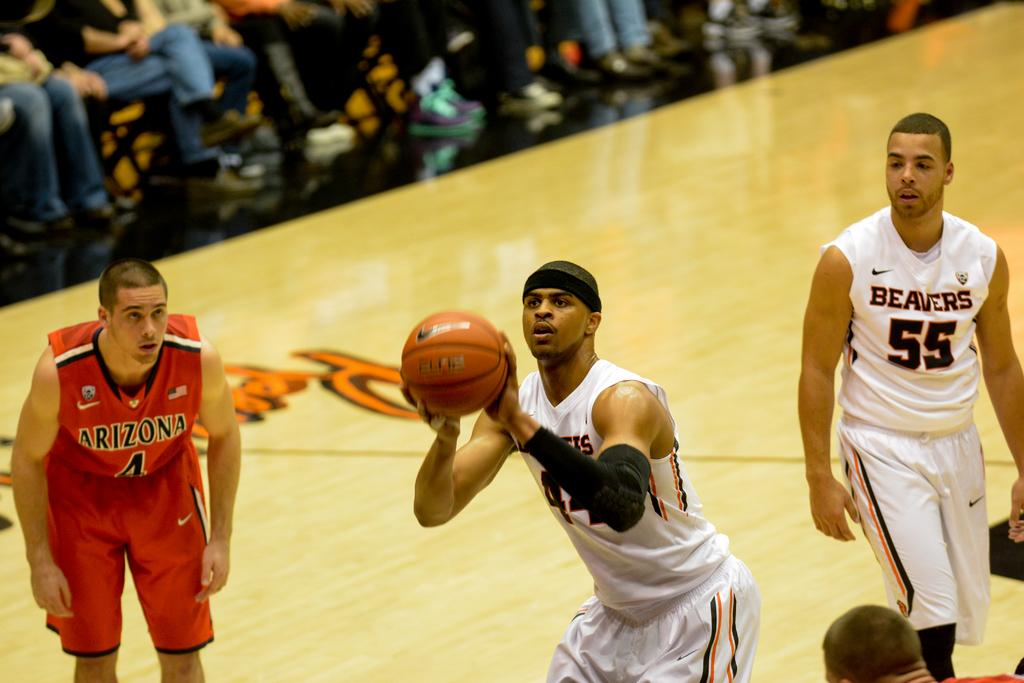<image>
Provide a brief description of the given image. beavers player shooting free throw while arizona player #4 waits to the side and beavers player #55 stands in the back 